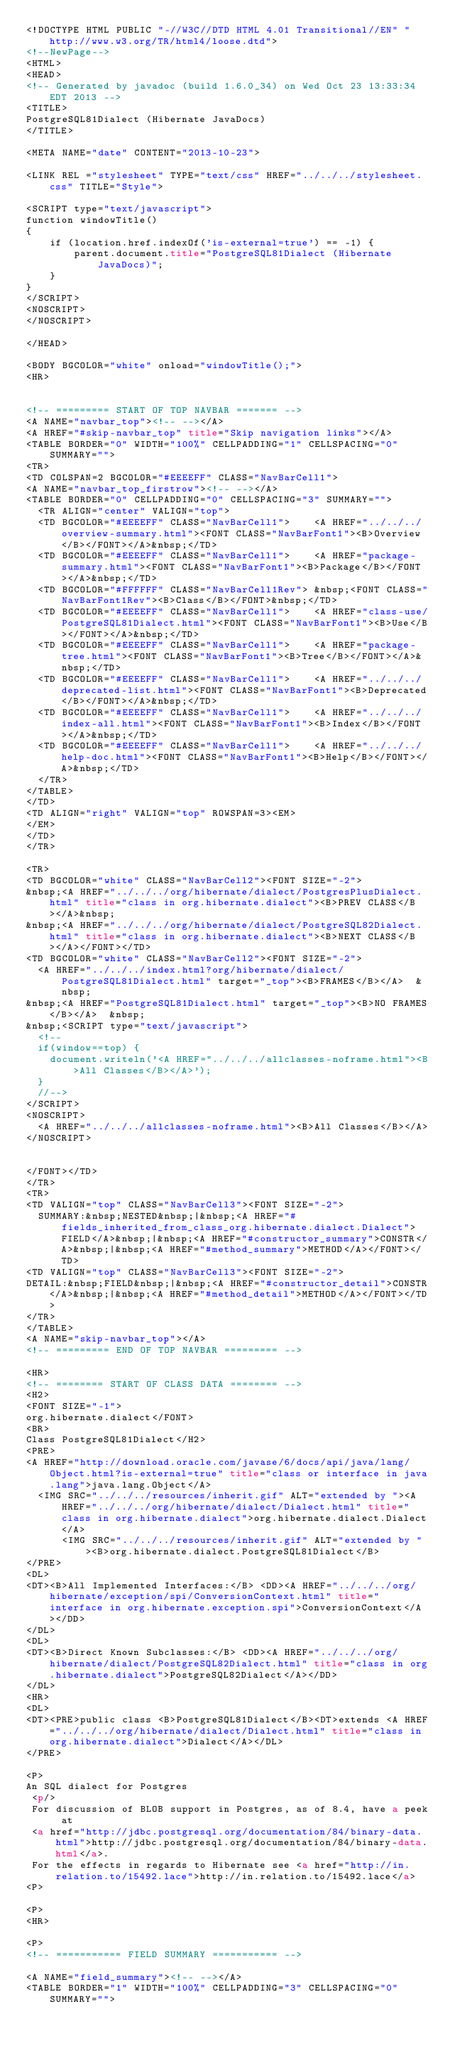<code> <loc_0><loc_0><loc_500><loc_500><_HTML_><!DOCTYPE HTML PUBLIC "-//W3C//DTD HTML 4.01 Transitional//EN" "http://www.w3.org/TR/html4/loose.dtd">
<!--NewPage-->
<HTML>
<HEAD>
<!-- Generated by javadoc (build 1.6.0_34) on Wed Oct 23 13:33:34 EDT 2013 -->
<TITLE>
PostgreSQL81Dialect (Hibernate JavaDocs)
</TITLE>

<META NAME="date" CONTENT="2013-10-23">

<LINK REL ="stylesheet" TYPE="text/css" HREF="../../../stylesheet.css" TITLE="Style">

<SCRIPT type="text/javascript">
function windowTitle()
{
    if (location.href.indexOf('is-external=true') == -1) {
        parent.document.title="PostgreSQL81Dialect (Hibernate JavaDocs)";
    }
}
</SCRIPT>
<NOSCRIPT>
</NOSCRIPT>

</HEAD>

<BODY BGCOLOR="white" onload="windowTitle();">
<HR>


<!-- ========= START OF TOP NAVBAR ======= -->
<A NAME="navbar_top"><!-- --></A>
<A HREF="#skip-navbar_top" title="Skip navigation links"></A>
<TABLE BORDER="0" WIDTH="100%" CELLPADDING="1" CELLSPACING="0" SUMMARY="">
<TR>
<TD COLSPAN=2 BGCOLOR="#EEEEFF" CLASS="NavBarCell1">
<A NAME="navbar_top_firstrow"><!-- --></A>
<TABLE BORDER="0" CELLPADDING="0" CELLSPACING="3" SUMMARY="">
  <TR ALIGN="center" VALIGN="top">
  <TD BGCOLOR="#EEEEFF" CLASS="NavBarCell1">    <A HREF="../../../overview-summary.html"><FONT CLASS="NavBarFont1"><B>Overview</B></FONT></A>&nbsp;</TD>
  <TD BGCOLOR="#EEEEFF" CLASS="NavBarCell1">    <A HREF="package-summary.html"><FONT CLASS="NavBarFont1"><B>Package</B></FONT></A>&nbsp;</TD>
  <TD BGCOLOR="#FFFFFF" CLASS="NavBarCell1Rev"> &nbsp;<FONT CLASS="NavBarFont1Rev"><B>Class</B></FONT>&nbsp;</TD>
  <TD BGCOLOR="#EEEEFF" CLASS="NavBarCell1">    <A HREF="class-use/PostgreSQL81Dialect.html"><FONT CLASS="NavBarFont1"><B>Use</B></FONT></A>&nbsp;</TD>
  <TD BGCOLOR="#EEEEFF" CLASS="NavBarCell1">    <A HREF="package-tree.html"><FONT CLASS="NavBarFont1"><B>Tree</B></FONT></A>&nbsp;</TD>
  <TD BGCOLOR="#EEEEFF" CLASS="NavBarCell1">    <A HREF="../../../deprecated-list.html"><FONT CLASS="NavBarFont1"><B>Deprecated</B></FONT></A>&nbsp;</TD>
  <TD BGCOLOR="#EEEEFF" CLASS="NavBarCell1">    <A HREF="../../../index-all.html"><FONT CLASS="NavBarFont1"><B>Index</B></FONT></A>&nbsp;</TD>
  <TD BGCOLOR="#EEEEFF" CLASS="NavBarCell1">    <A HREF="../../../help-doc.html"><FONT CLASS="NavBarFont1"><B>Help</B></FONT></A>&nbsp;</TD>
  </TR>
</TABLE>
</TD>
<TD ALIGN="right" VALIGN="top" ROWSPAN=3><EM>
</EM>
</TD>
</TR>

<TR>
<TD BGCOLOR="white" CLASS="NavBarCell2"><FONT SIZE="-2">
&nbsp;<A HREF="../../../org/hibernate/dialect/PostgresPlusDialect.html" title="class in org.hibernate.dialect"><B>PREV CLASS</B></A>&nbsp;
&nbsp;<A HREF="../../../org/hibernate/dialect/PostgreSQL82Dialect.html" title="class in org.hibernate.dialect"><B>NEXT CLASS</B></A></FONT></TD>
<TD BGCOLOR="white" CLASS="NavBarCell2"><FONT SIZE="-2">
  <A HREF="../../../index.html?org/hibernate/dialect/PostgreSQL81Dialect.html" target="_top"><B>FRAMES</B></A>  &nbsp;
&nbsp;<A HREF="PostgreSQL81Dialect.html" target="_top"><B>NO FRAMES</B></A>  &nbsp;
&nbsp;<SCRIPT type="text/javascript">
  <!--
  if(window==top) {
    document.writeln('<A HREF="../../../allclasses-noframe.html"><B>All Classes</B></A>');
  }
  //-->
</SCRIPT>
<NOSCRIPT>
  <A HREF="../../../allclasses-noframe.html"><B>All Classes</B></A>
</NOSCRIPT>


</FONT></TD>
</TR>
<TR>
<TD VALIGN="top" CLASS="NavBarCell3"><FONT SIZE="-2">
  SUMMARY:&nbsp;NESTED&nbsp;|&nbsp;<A HREF="#fields_inherited_from_class_org.hibernate.dialect.Dialect">FIELD</A>&nbsp;|&nbsp;<A HREF="#constructor_summary">CONSTR</A>&nbsp;|&nbsp;<A HREF="#method_summary">METHOD</A></FONT></TD>
<TD VALIGN="top" CLASS="NavBarCell3"><FONT SIZE="-2">
DETAIL:&nbsp;FIELD&nbsp;|&nbsp;<A HREF="#constructor_detail">CONSTR</A>&nbsp;|&nbsp;<A HREF="#method_detail">METHOD</A></FONT></TD>
</TR>
</TABLE>
<A NAME="skip-navbar_top"></A>
<!-- ========= END OF TOP NAVBAR ========= -->

<HR>
<!-- ======== START OF CLASS DATA ======== -->
<H2>
<FONT SIZE="-1">
org.hibernate.dialect</FONT>
<BR>
Class PostgreSQL81Dialect</H2>
<PRE>
<A HREF="http://download.oracle.com/javase/6/docs/api/java/lang/Object.html?is-external=true" title="class or interface in java.lang">java.lang.Object</A>
  <IMG SRC="../../../resources/inherit.gif" ALT="extended by "><A HREF="../../../org/hibernate/dialect/Dialect.html" title="class in org.hibernate.dialect">org.hibernate.dialect.Dialect</A>
      <IMG SRC="../../../resources/inherit.gif" ALT="extended by "><B>org.hibernate.dialect.PostgreSQL81Dialect</B>
</PRE>
<DL>
<DT><B>All Implemented Interfaces:</B> <DD><A HREF="../../../org/hibernate/exception/spi/ConversionContext.html" title="interface in org.hibernate.exception.spi">ConversionContext</A></DD>
</DL>
<DL>
<DT><B>Direct Known Subclasses:</B> <DD><A HREF="../../../org/hibernate/dialect/PostgreSQL82Dialect.html" title="class in org.hibernate.dialect">PostgreSQL82Dialect</A></DD>
</DL>
<HR>
<DL>
<DT><PRE>public class <B>PostgreSQL81Dialect</B><DT>extends <A HREF="../../../org/hibernate/dialect/Dialect.html" title="class in org.hibernate.dialect">Dialect</A></DL>
</PRE>

<P>
An SQL dialect for Postgres
 <p/>
 For discussion of BLOB support in Postgres, as of 8.4, have a peek at
 <a href="http://jdbc.postgresql.org/documentation/84/binary-data.html">http://jdbc.postgresql.org/documentation/84/binary-data.html</a>.
 For the effects in regards to Hibernate see <a href="http://in.relation.to/15492.lace">http://in.relation.to/15492.lace</a>
<P>

<P>
<HR>

<P>
<!-- =========== FIELD SUMMARY =========== -->

<A NAME="field_summary"><!-- --></A>
<TABLE BORDER="1" WIDTH="100%" CELLPADDING="3" CELLSPACING="0" SUMMARY=""></code> 